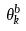Convert formula to latex. <formula><loc_0><loc_0><loc_500><loc_500>\theta _ { k } ^ { b }</formula> 